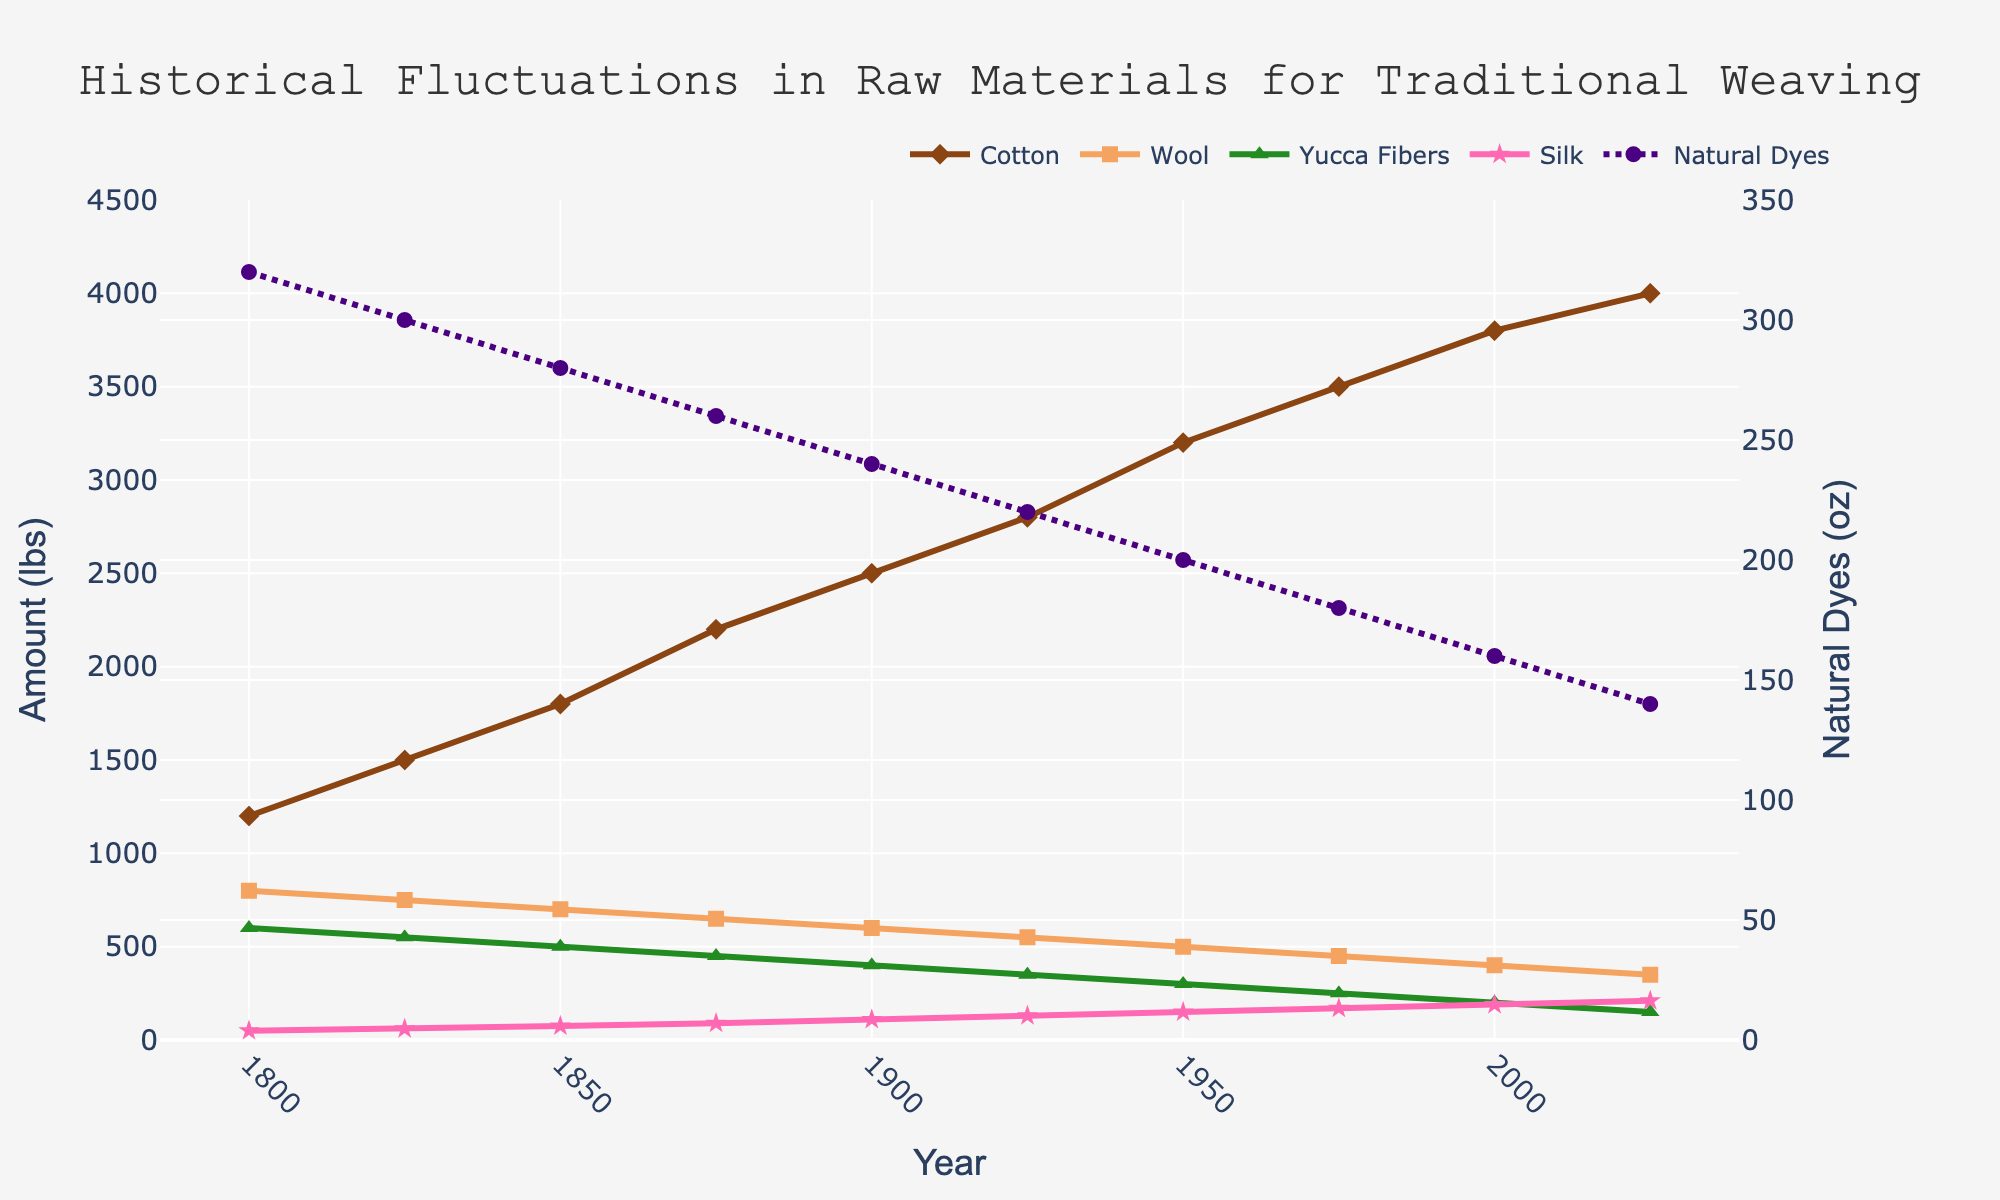Which raw material had the highest availability in 2000? To determine this, we look across all raw materials in the year 2000. The values are: Cotton (3800 lbs), Wool (400 lbs), Yucca Fibers (200 lbs), Natural Dyes (160 oz), and Silk (190 lbs). Cotton has the highest value.
Answer: Cotton How has the availability of wool changed from 1800 to 2025? We compare the values of Wool in 1800 and 2025. In 1800, it was 800 lbs. In 2025, it is 350 lbs. Wool's availability has decreased over this period.
Answer: Decreased What is the average amount of natural dyes available in 1800 and 2025? The values of Natural Dyes in 1800 and 2025 are 320 oz and 140 oz respectively. The sum is (320 + 140) = 460 oz. The average is 460 / 2 = 230 oz.
Answer: 230 oz Which raw material has shown continuous growth from 1800 to 2025? By observing each material's trend from 1800 to 2025, Cotton shows continuous growth, with increasing values across all years. Other materials fluctuate or decrease.
Answer: Cotton Which raw material had the least availability in 1950? We compare the values for 1950: Cotton (3200 lbs), Wool (500 lbs), Yucca Fibers (300 lbs), Natural Dyes (200 oz), and Silk (150 lbs). Silk with 150 lbs has the least availability.
Answer: Silk What is the difference in availability of Yucca fibers between 1800 and 2000? Yucca Fibers in 1800 is 600 lbs and in 2000 is 200 lbs. The difference is 600 - 200 = 400 lbs.
Answer: 400 lbs How does the availability of Natural Dyes in 1850 compare visually to other years? Natural Dyes in 1850 (280 oz) has a slightly lower value compared to 1800 (320 oz) and shows a gradual decrease over subsequent years. Visually, it has the third highest value among the years provided.
Answer: Slightly lower Between which two consecutive years did Silk see the largest increase in availability? We analyze the differences between the consecutive years: 
1825-1800: 60-50 = 10 lbs,
1850-1825: 75-60 = 15 lbs,
1875-1850: 90-75 = 15 lbs,
1900-1875: 110-90 = 20 lbs,
1925-1900: 130-110 = 20 lbs,
1950-1925: 150-130 = 20 lbs,
1975-1950: 170-150 = 20 lbs,
2000-1975: 190-170 = 20 lbs,
2025-2000: 210-190 = 20 lbs.
The consecutive year with the largest increase is 1900 to 1925, and 1925 to 1950, and other 4 years all have an increase of 20 lbs.
Answer: 1925-1950, 1975-1950, 2000-1975, 2025-2000 and 1900-1925 